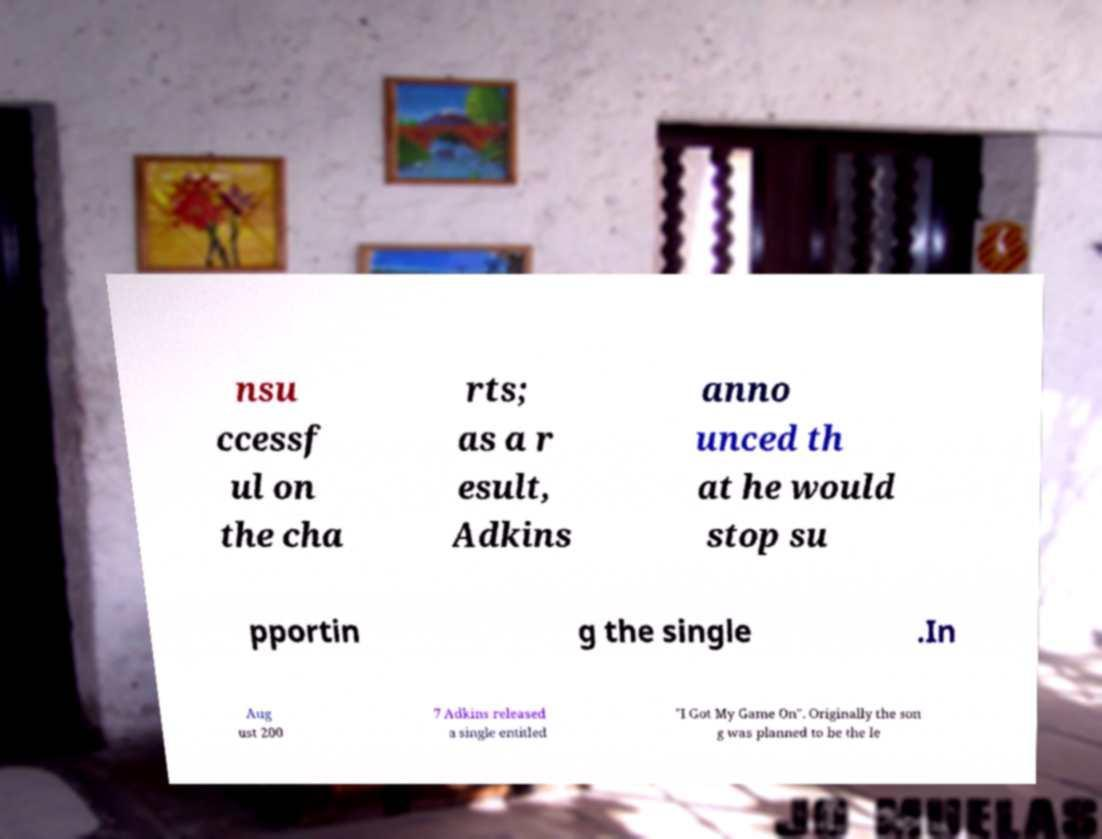Could you assist in decoding the text presented in this image and type it out clearly? nsu ccessf ul on the cha rts; as a r esult, Adkins anno unced th at he would stop su pportin g the single .In Aug ust 200 7 Adkins released a single entitled "I Got My Game On". Originally the son g was planned to be the le 